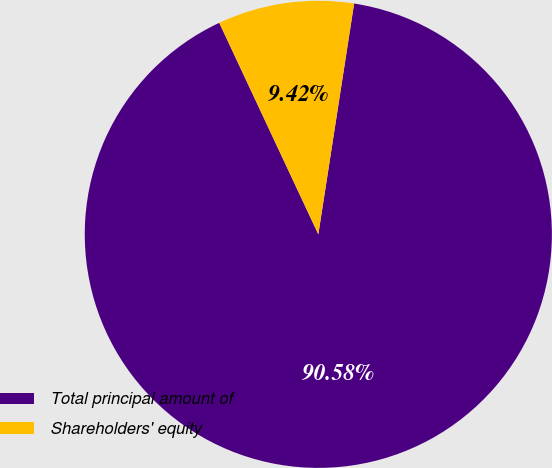Convert chart. <chart><loc_0><loc_0><loc_500><loc_500><pie_chart><fcel>Total principal amount of<fcel>Shareholders' equity<nl><fcel>90.58%<fcel>9.42%<nl></chart> 